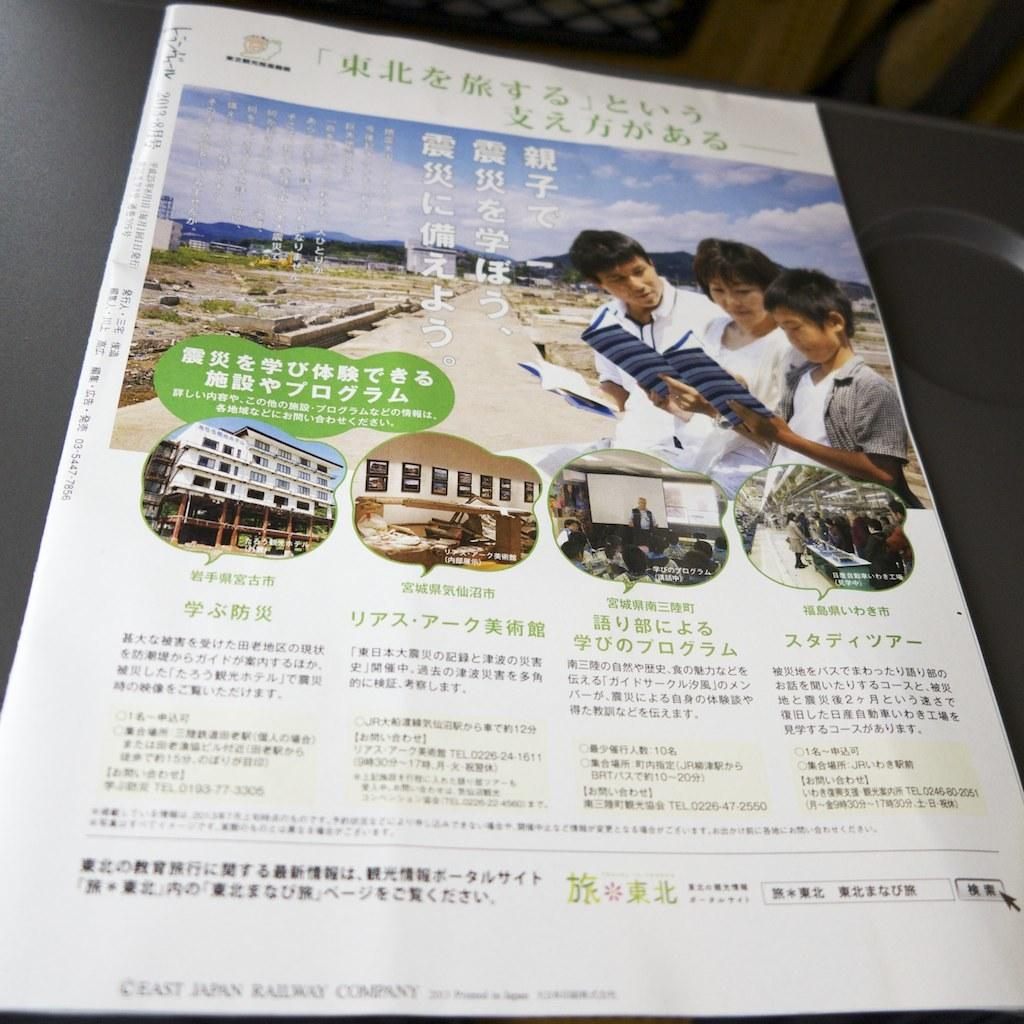What type of visual is the image? The image appears to be a poster. What subjects are depicted on the poster? There are people and buildings depicted on the poster. Is there any text present on the poster? Yes, there is text present on the poster. Can you see a basket filled with letters in the image? There is no basket filled with letters present in the image. Is there a stocking hanging from one of the buildings depicted on the poster? There is no stocking hanging from any of the buildings depicted on the poster. 